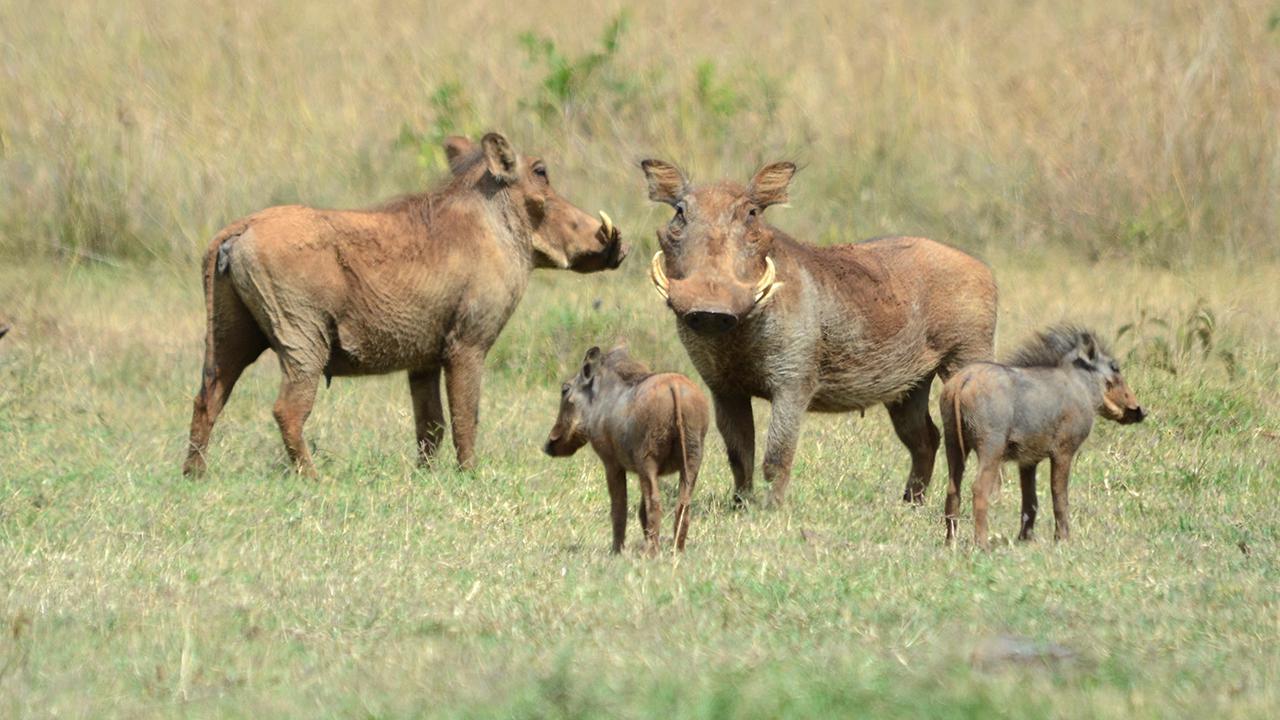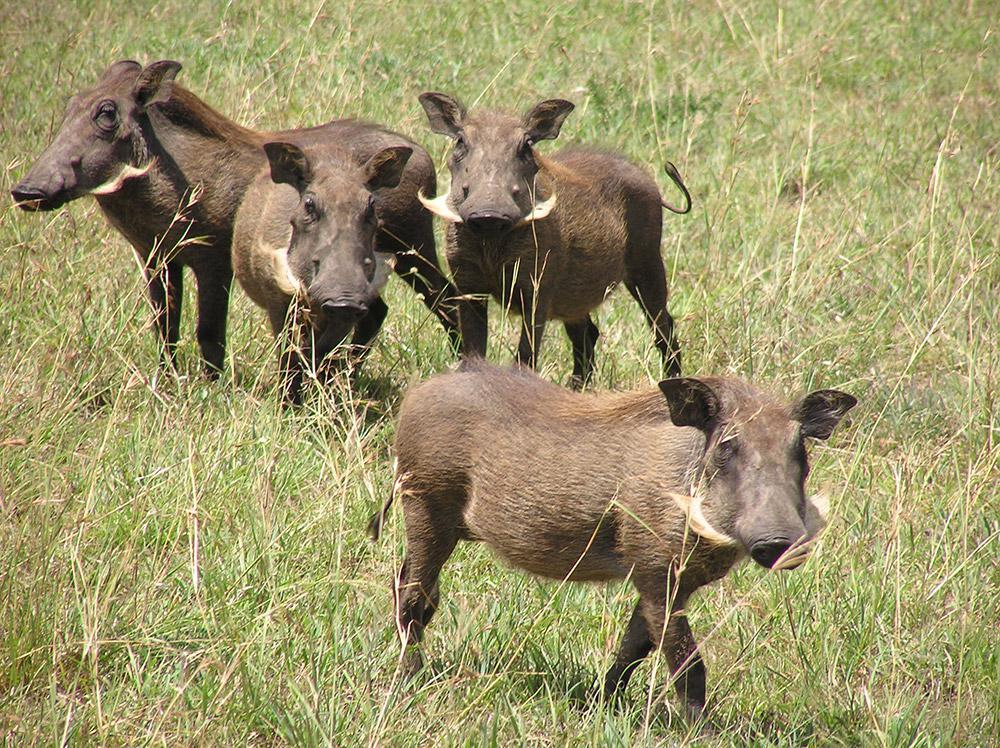The first image is the image on the left, the second image is the image on the right. Analyze the images presented: Is the assertion "There are exactly five animals in the image on the right." valid? Answer yes or no. No. 